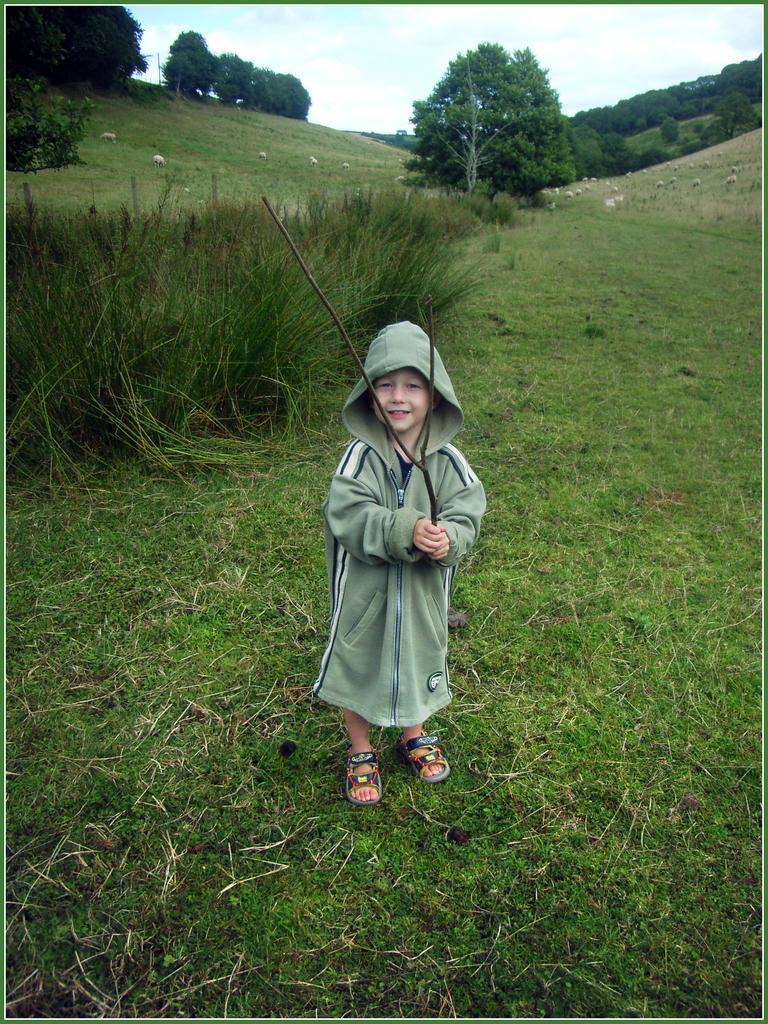Can you describe this image briefly? In this picture we can see a kid standing here, a kid is holding a stick, at the bottom there is grass, we can see some trees in the background, there is the sky at the top of the picture. 